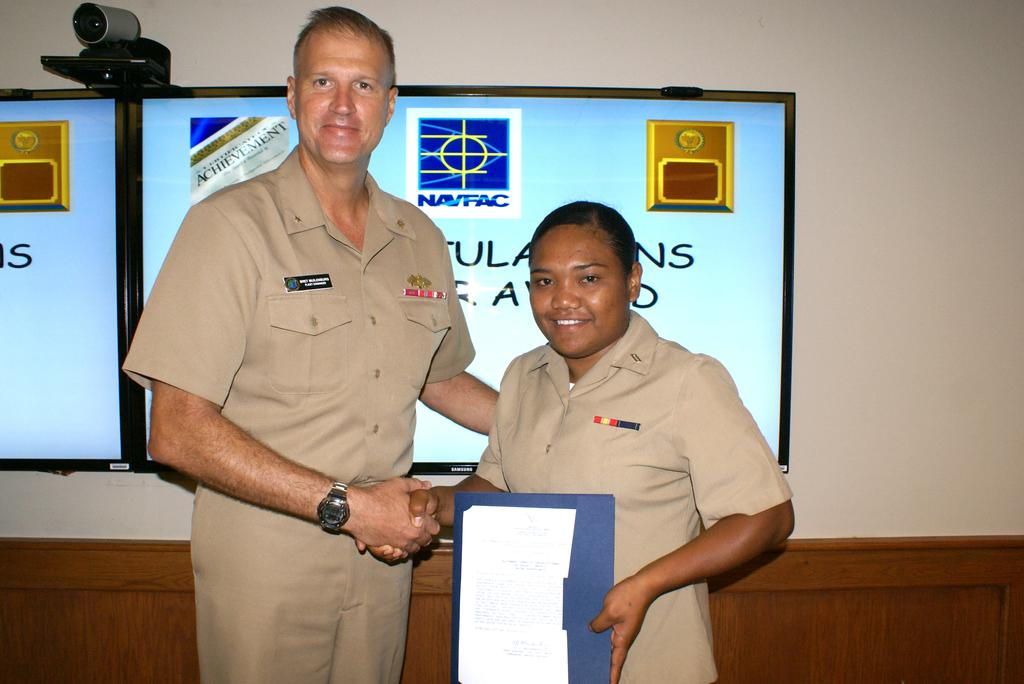How many people are in the image? There are two persons in the image. What is the facial expression of the persons in the image? The persons are smiling. What can be seen in the background of the image? There is a wall and screens in the background of the image. What type of loaf is being prepared by the persons in the image? There is no loaf or any indication of food preparation in the image. What emotion other than happiness might be displayed by the persons in the image? The persons are smiling, which suggests they are happy, and there is no indication of anger or any other negative emotion in the image. 